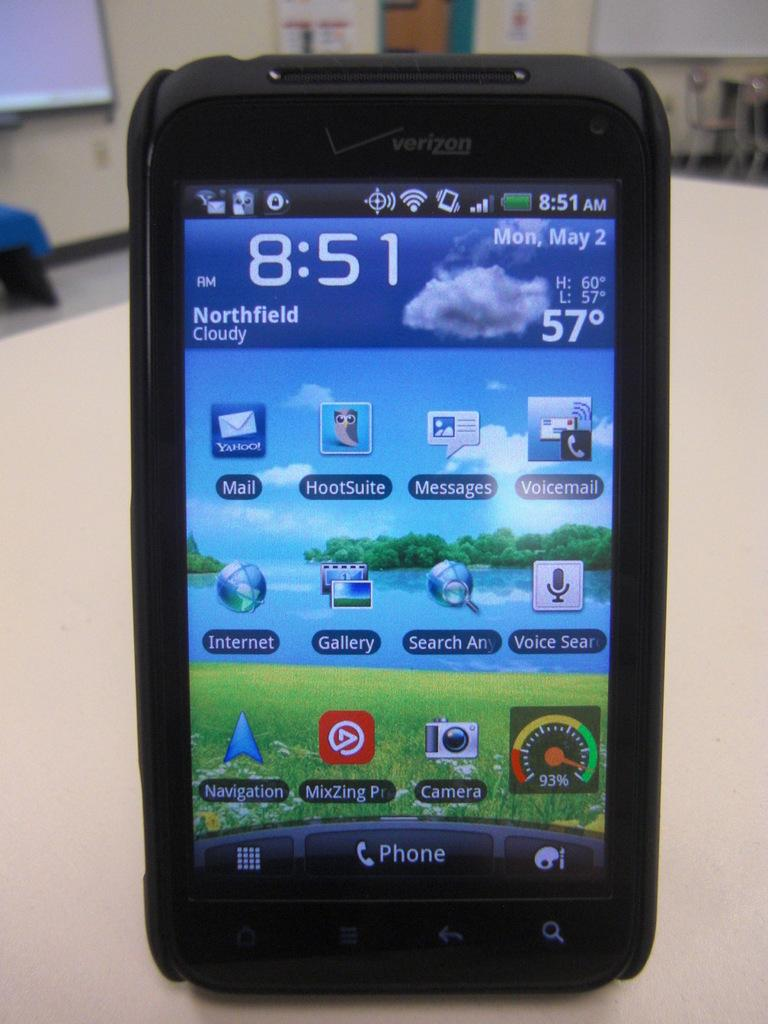Provide a one-sentence caption for the provided image. A cellphone screen that says the time of 8:51. 